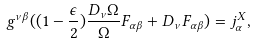<formula> <loc_0><loc_0><loc_500><loc_500>g ^ { \nu \beta } ( ( 1 - \frac { \epsilon } { 2 } ) \frac { D _ { \nu } \Omega } { \Omega } F _ { \alpha \beta } + D _ { \nu } F _ { \alpha \beta } ) = j ^ { X } _ { \alpha } ,</formula> 